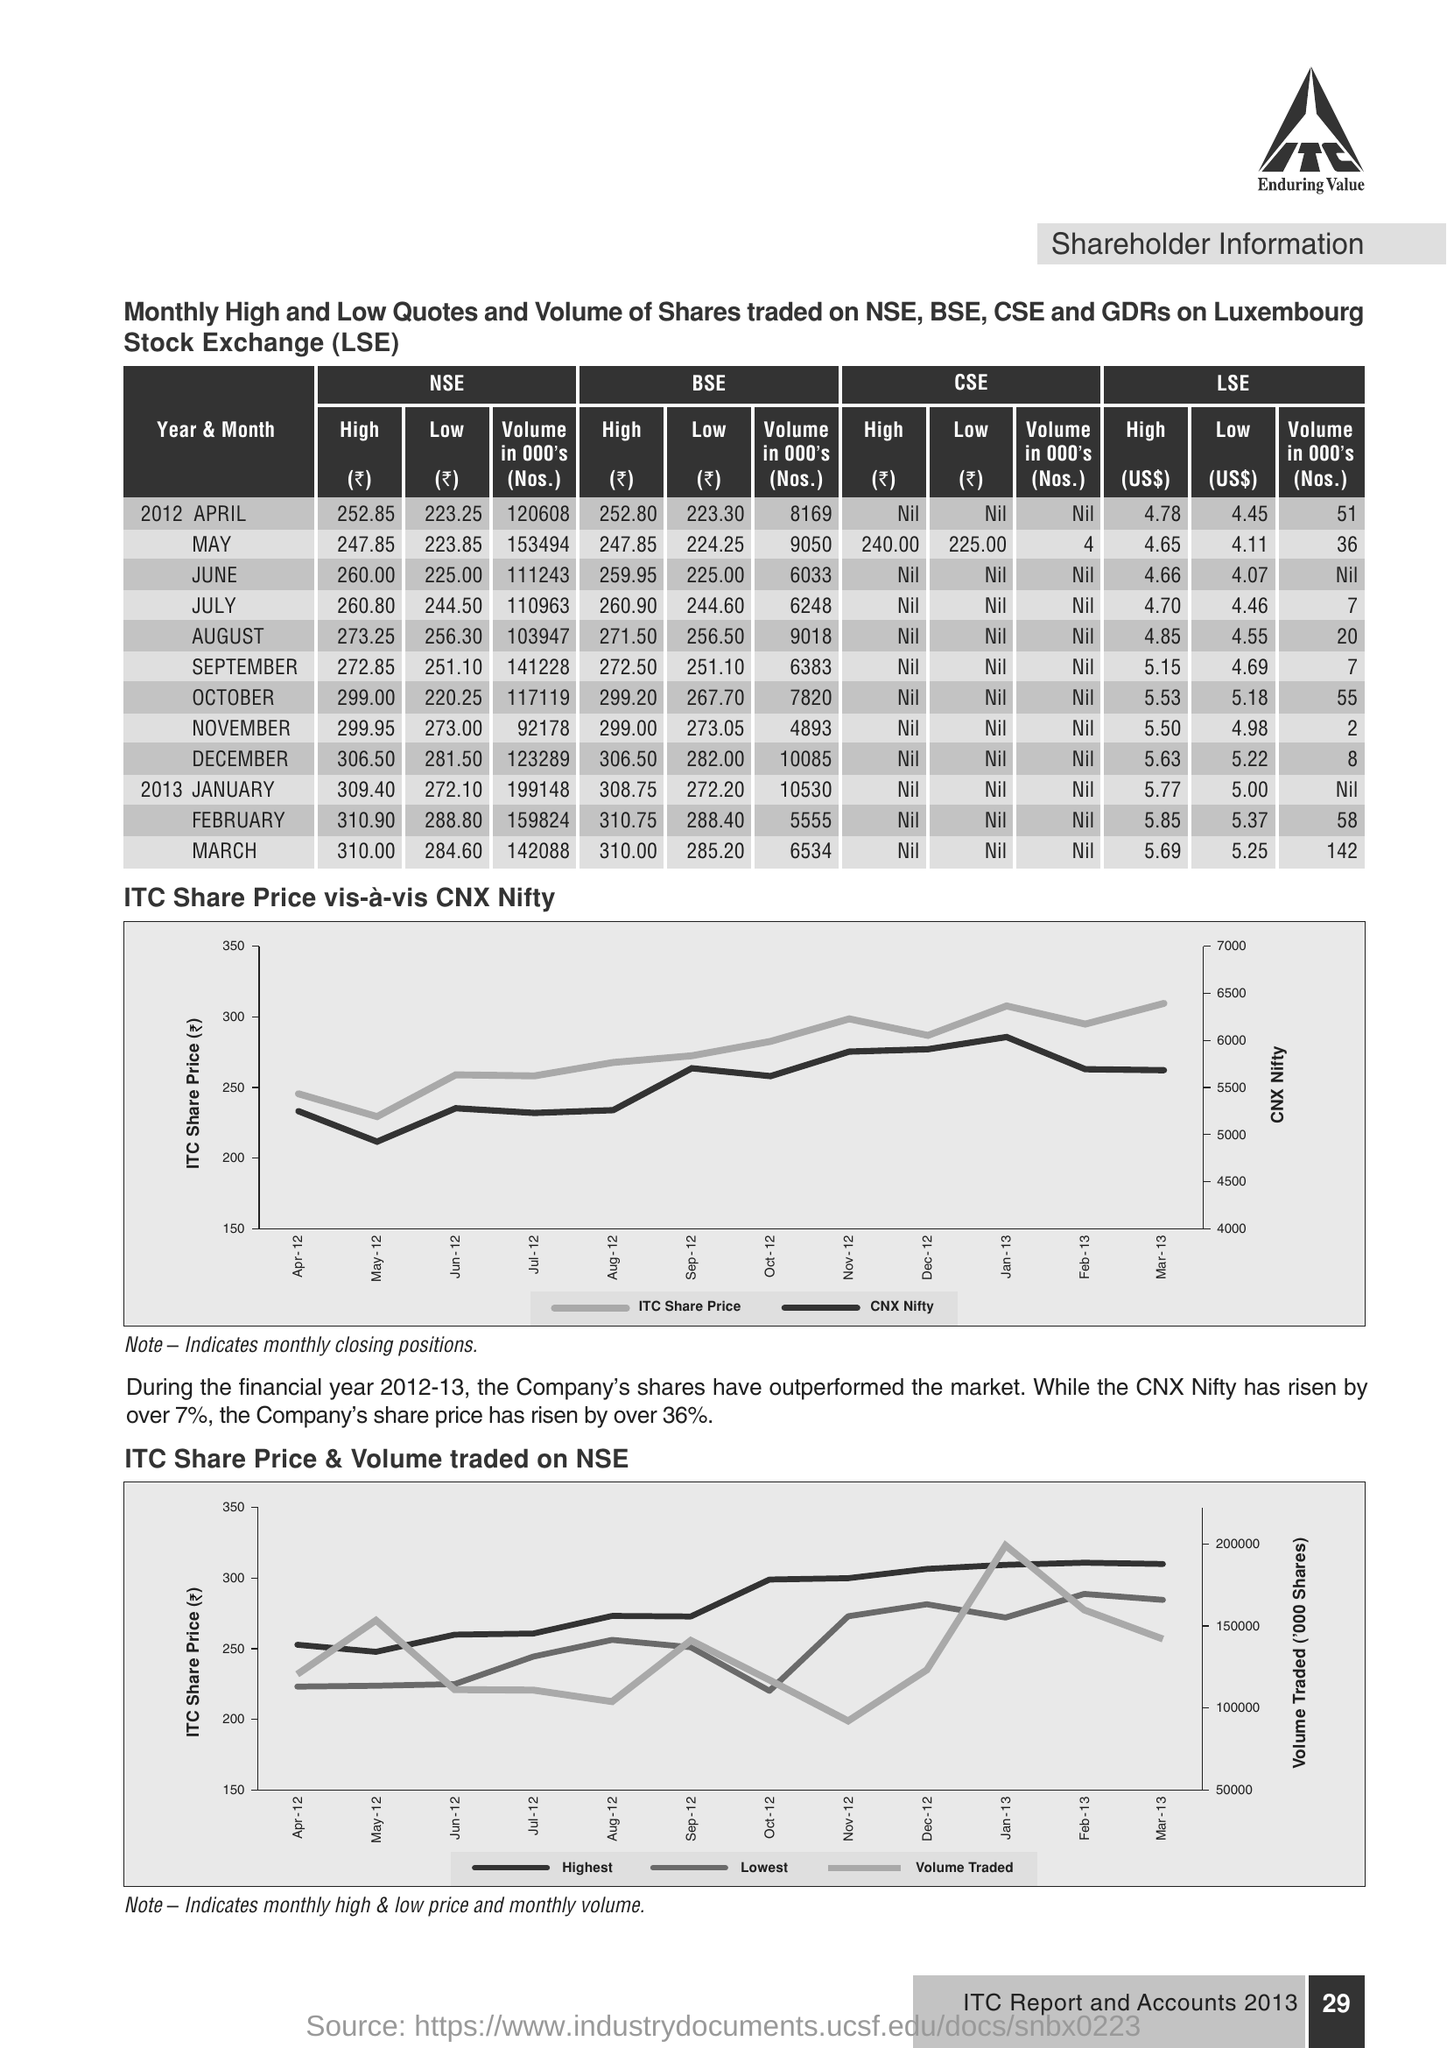What is the Information showing this document ?
Your answer should be very brief. Shareholder information. How much NSE volume in May month ?
Your answer should be compact. 153494. What is the High amount of BSE in August ?
Provide a succinct answer. 271.50. 